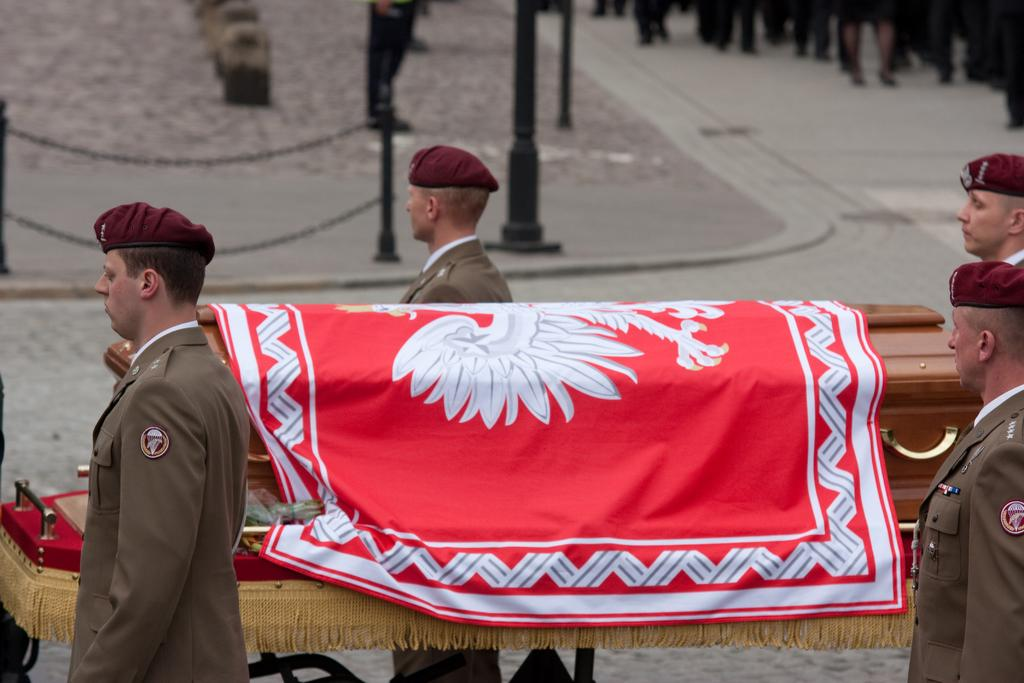How many people are present in the image? There are four persons standing in the image. What object is covered with a cloth in the image? There is a coffin with a cloth on it. What type of barriers are present in the image? There are chain barriers in the image. What can be seen in the background of the image? In the background, there are legs of a group of people. What type of iron is being used by the cows in the image? There are no cows present in the image, and therefore no iron can be associated with them. 